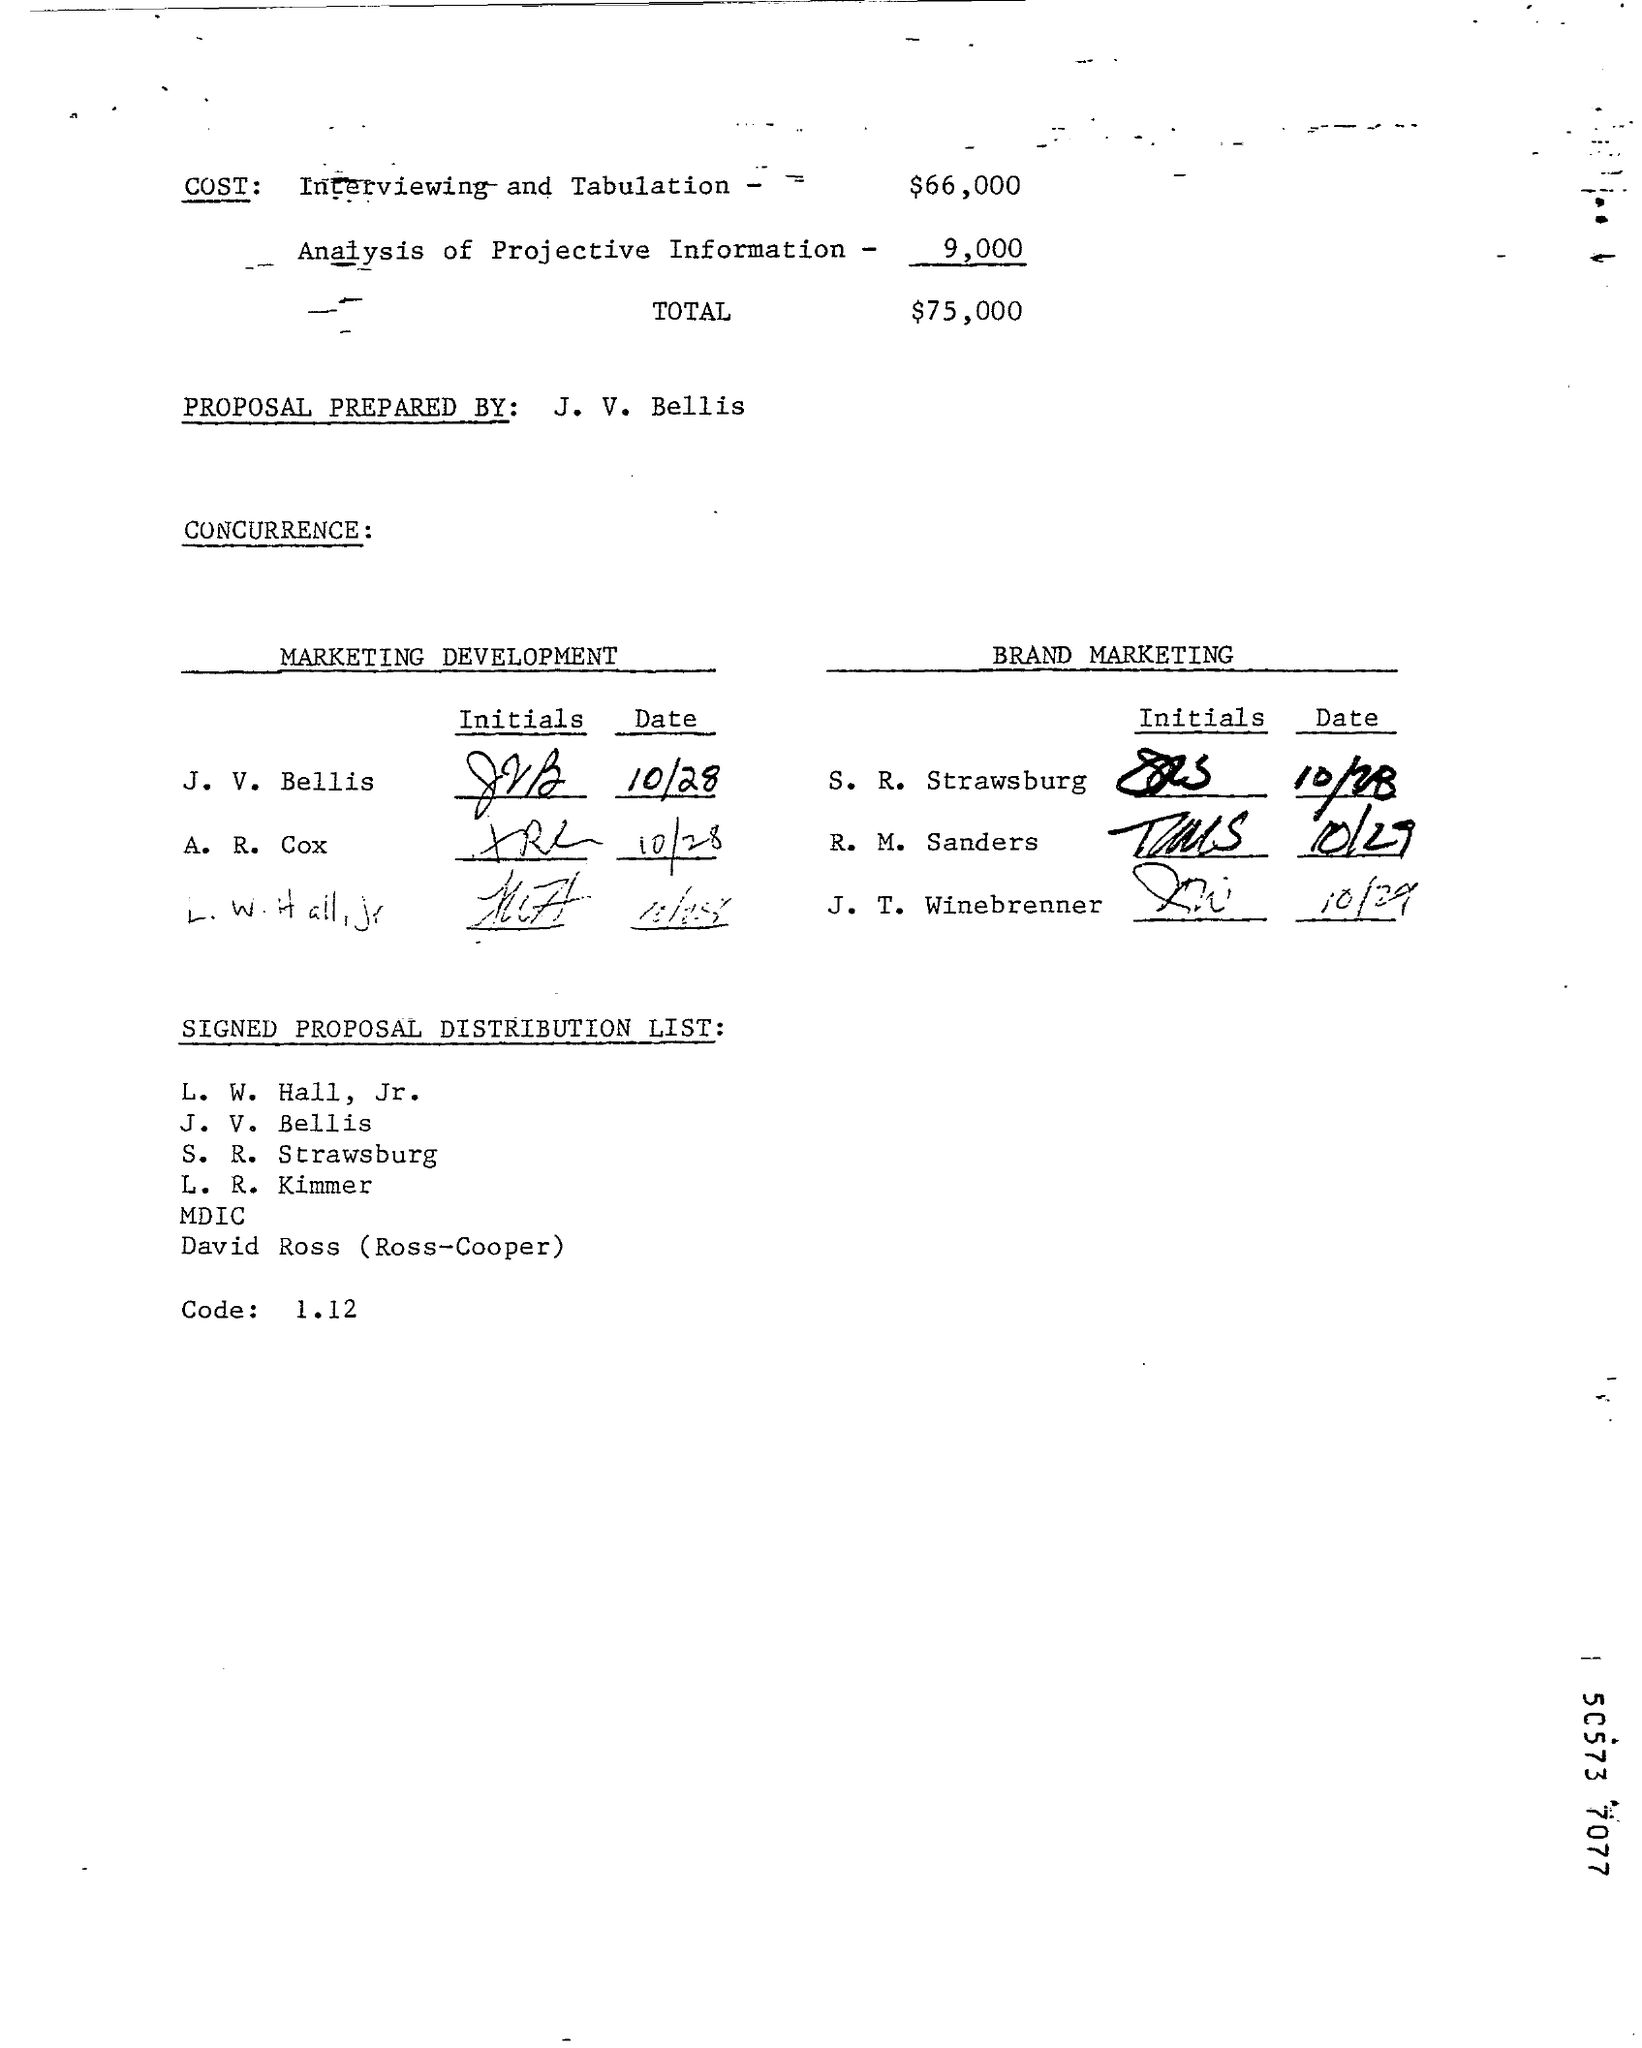What is the Cost of Interviewing and Tabulation?
Provide a short and direct response. $66,000. What is the Cost of Analysis of Projective Information?
Ensure brevity in your answer.  9,000. What is the Total Cost?
Provide a short and direct response. $75,000. Proposal Prepared by whom?
Keep it short and to the point. J. V. Bellis. 